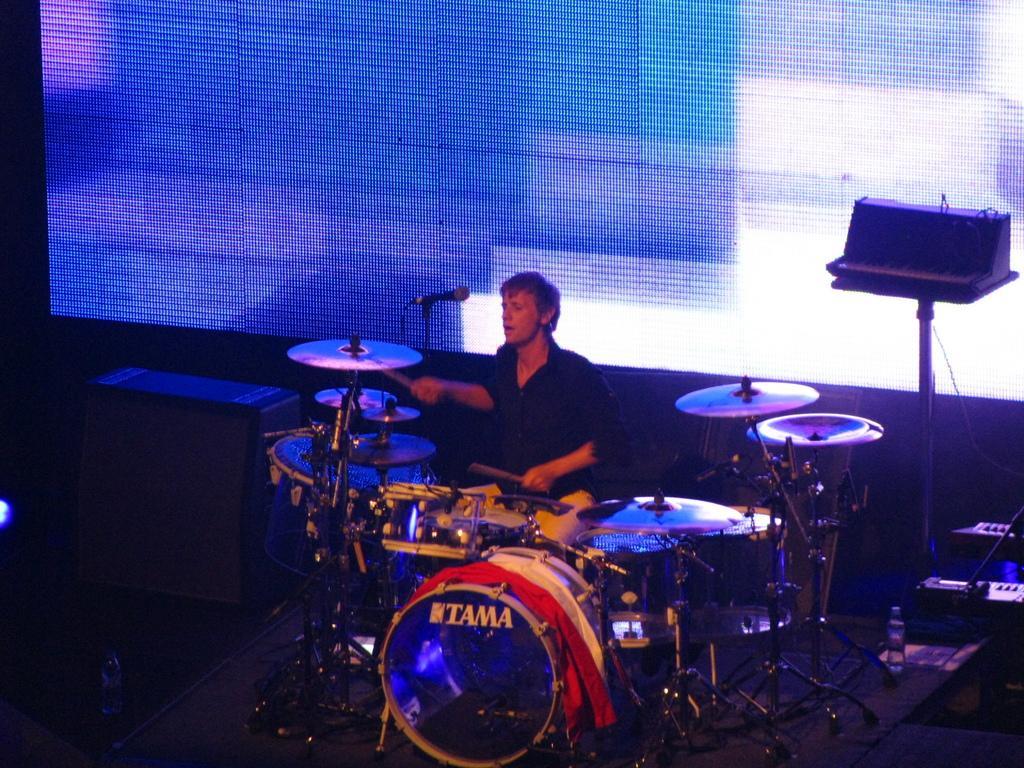Could you give a brief overview of what you see in this image? There is a boy in the center of the image, by holding sticks in his hands in front of a drum set and there is a speaker on the right side and there is a screen in the background area. 